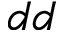Convert formula to latex. <formula><loc_0><loc_0><loc_500><loc_500>d d</formula> 